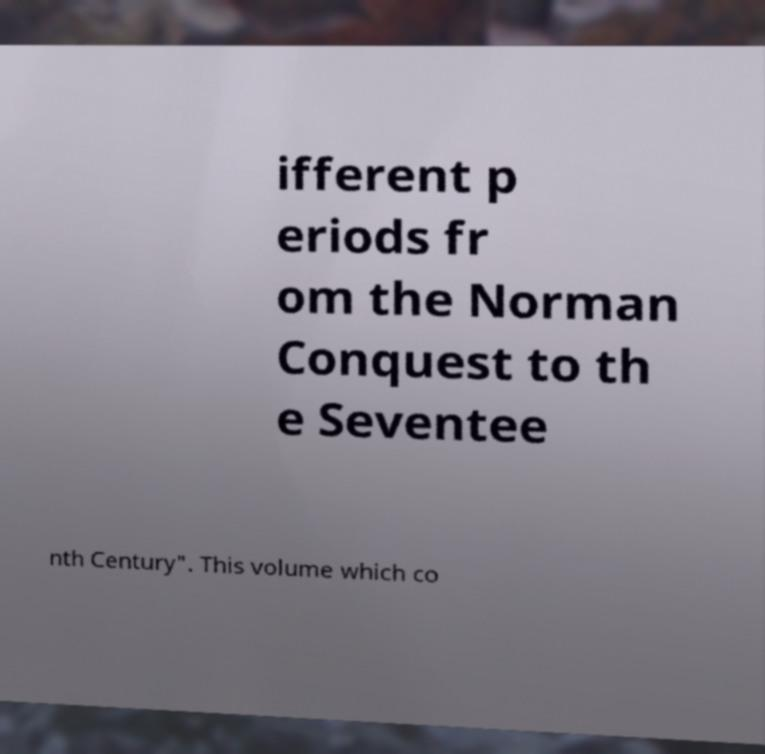There's text embedded in this image that I need extracted. Can you transcribe it verbatim? ifferent p eriods fr om the Norman Conquest to th e Seventee nth Century". This volume which co 